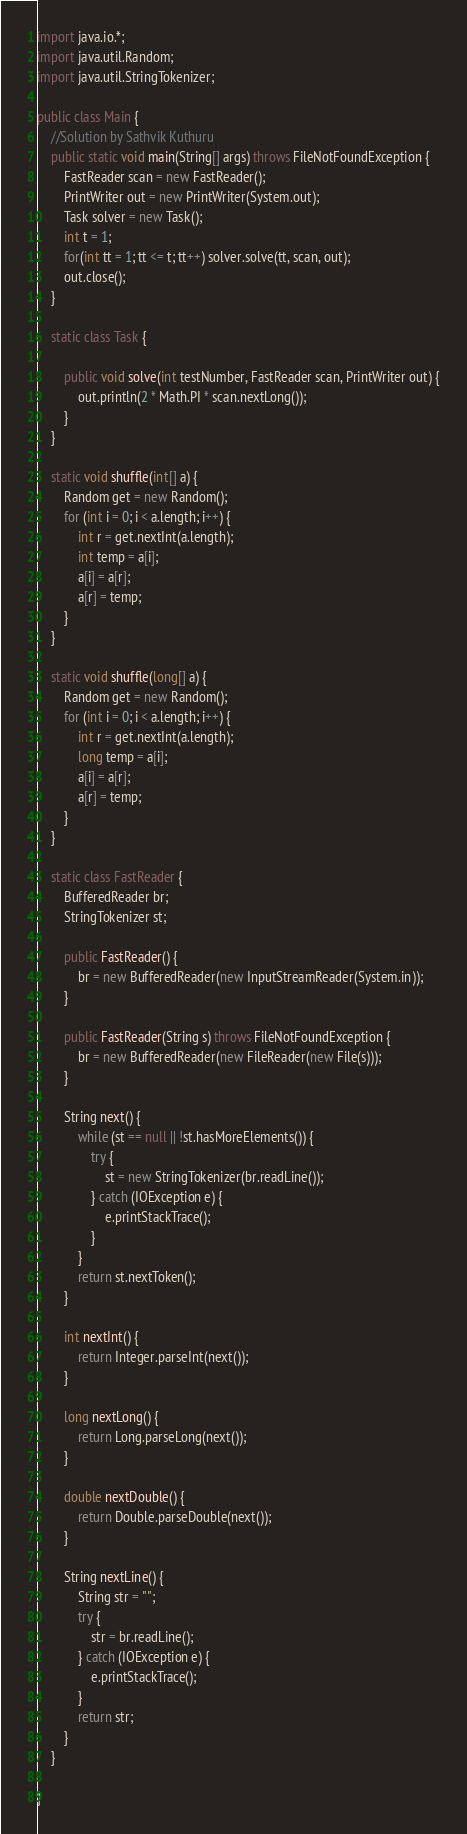<code> <loc_0><loc_0><loc_500><loc_500><_Java_>import java.io.*;
import java.util.Random;
import java.util.StringTokenizer;

public class Main {
    //Solution by Sathvik Kuthuru
    public static void main(String[] args) throws FileNotFoundException {
        FastReader scan = new FastReader();
        PrintWriter out = new PrintWriter(System.out);
        Task solver = new Task();
        int t = 1;
        for(int tt = 1; tt <= t; tt++) solver.solve(tt, scan, out);
        out.close();
    }

    static class Task {

        public void solve(int testNumber, FastReader scan, PrintWriter out) {
            out.println(2 * Math.PI * scan.nextLong());
        }
    }

    static void shuffle(int[] a) {
        Random get = new Random();
        for (int i = 0; i < a.length; i++) {
            int r = get.nextInt(a.length);
            int temp = a[i];
            a[i] = a[r];
            a[r] = temp;
        }
    }

    static void shuffle(long[] a) {
        Random get = new Random();
        for (int i = 0; i < a.length; i++) {
            int r = get.nextInt(a.length);
            long temp = a[i];
            a[i] = a[r];
            a[r] = temp;
        }
    }

    static class FastReader {
        BufferedReader br;
        StringTokenizer st;

        public FastReader() {
            br = new BufferedReader(new InputStreamReader(System.in));
        }

        public FastReader(String s) throws FileNotFoundException {
            br = new BufferedReader(new FileReader(new File(s)));
        }

        String next() {
            while (st == null || !st.hasMoreElements()) {
                try {
                    st = new StringTokenizer(br.readLine());
                } catch (IOException e) {
                    e.printStackTrace();
                }
            }
            return st.nextToken();
        }

        int nextInt() {
            return Integer.parseInt(next());
        }

        long nextLong() {
            return Long.parseLong(next());
        }

        double nextDouble() {
            return Double.parseDouble(next());
        }

        String nextLine() {
            String str = "";
            try {
                str = br.readLine();
            } catch (IOException e) {
                e.printStackTrace();
            }
            return str;
        }
    }

}</code> 